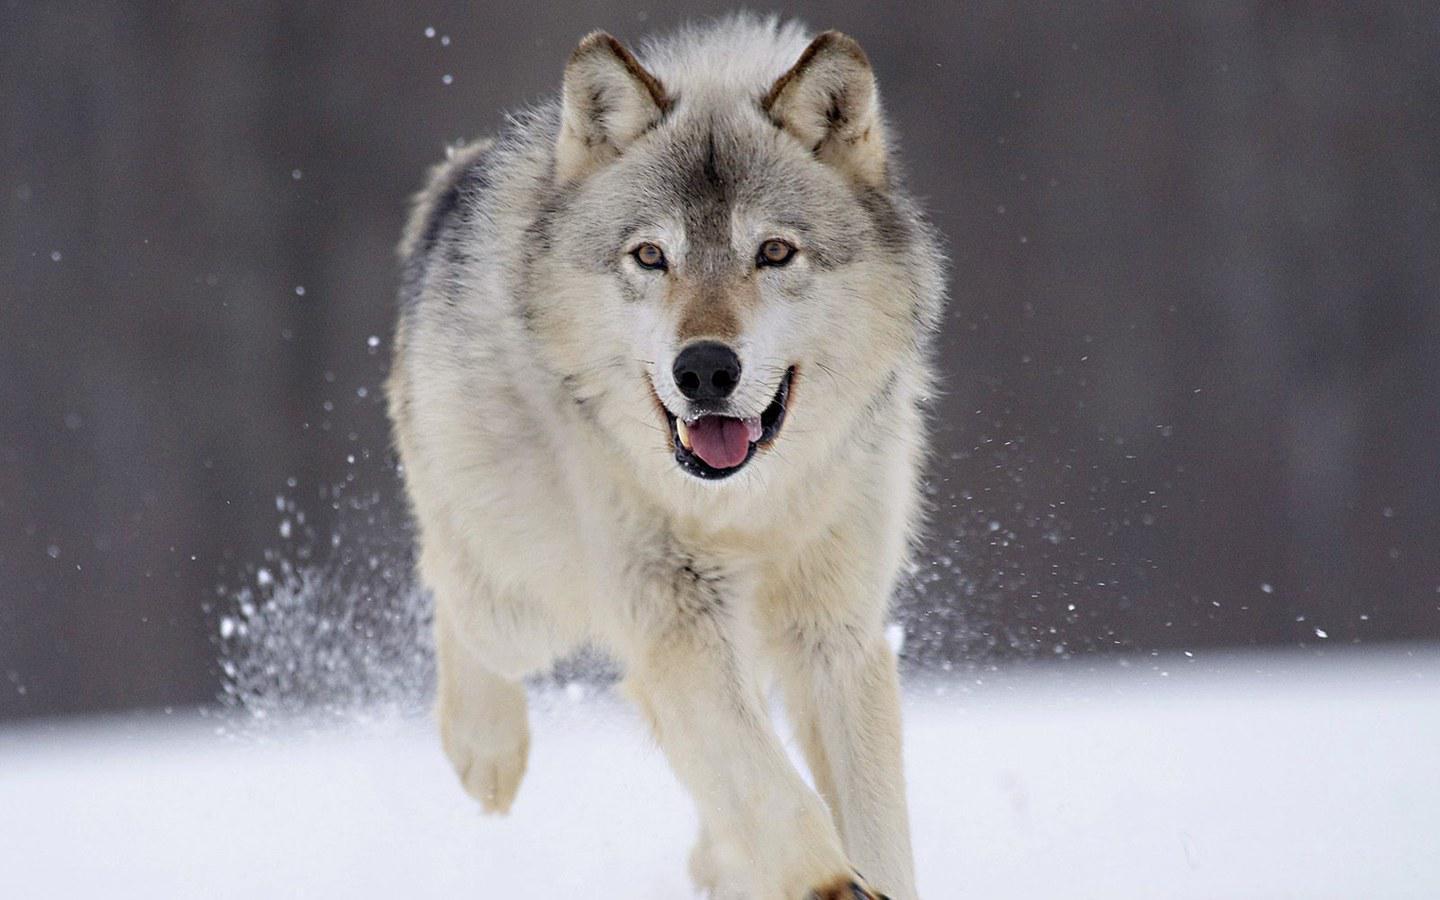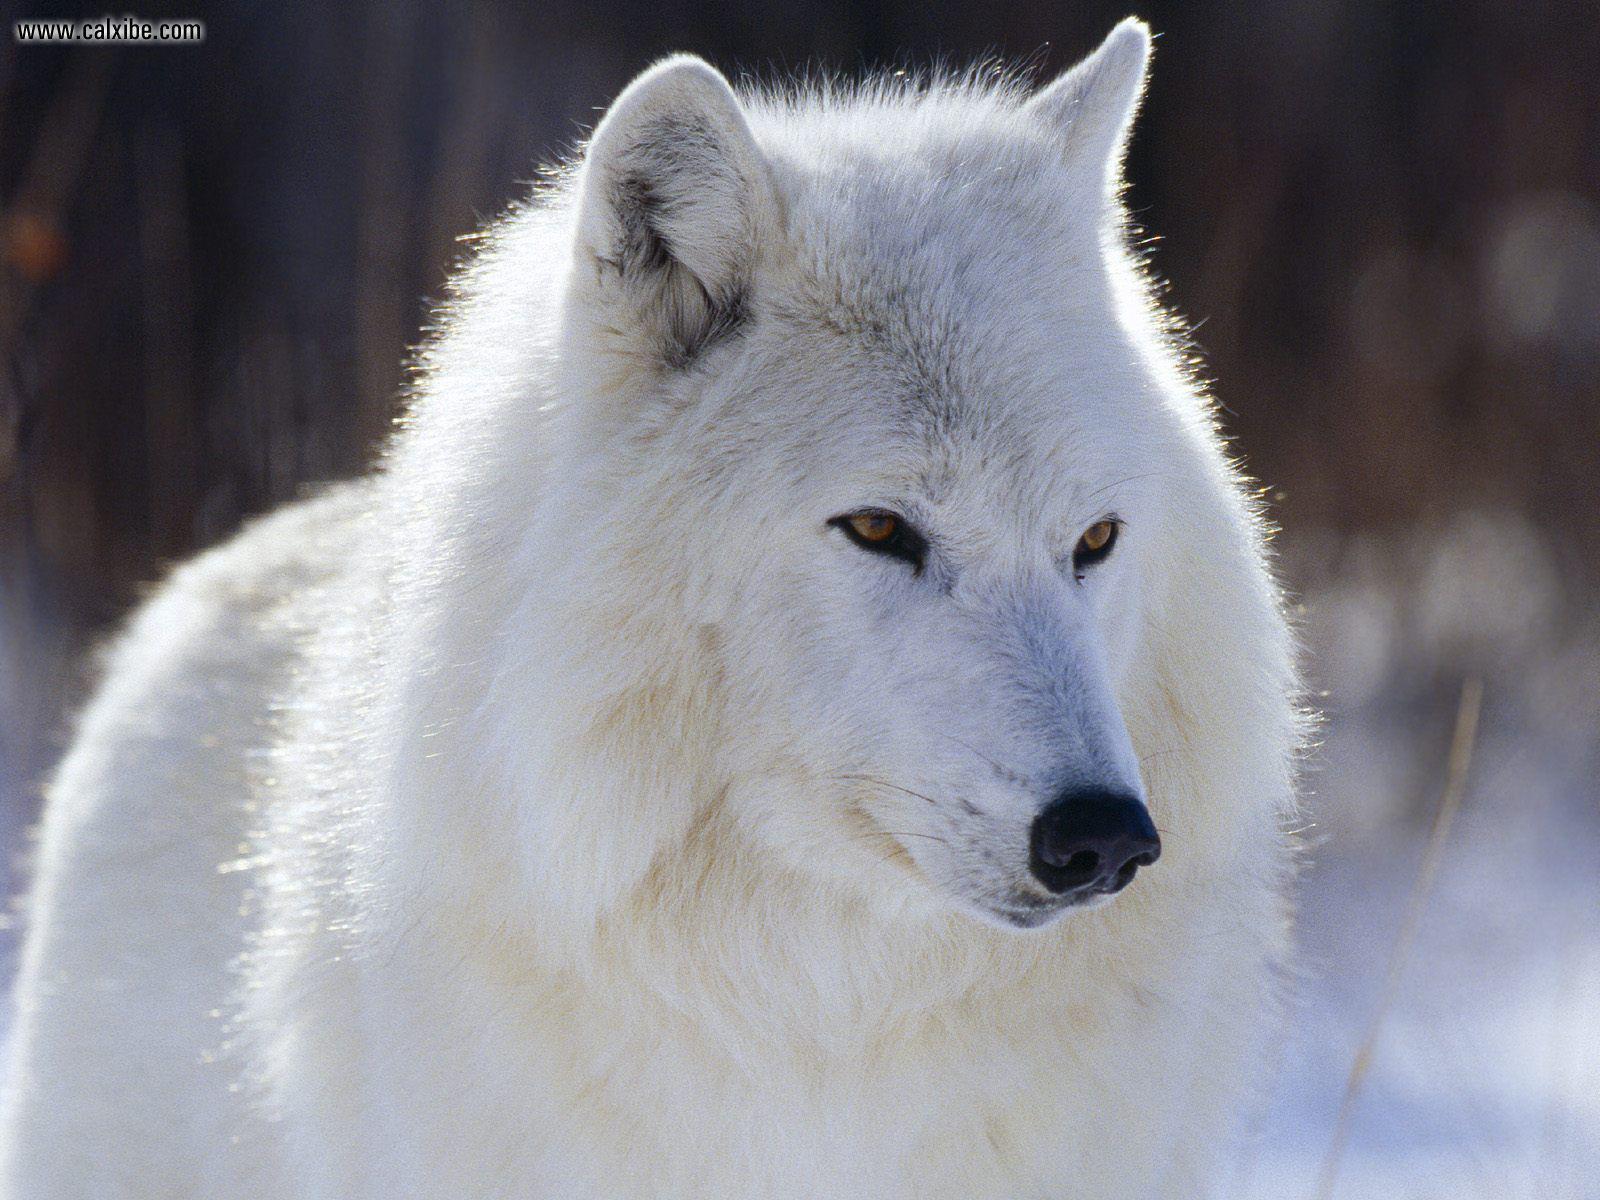The first image is the image on the left, the second image is the image on the right. Evaluate the accuracy of this statement regarding the images: "The left image includes a dog moving forward over snow toward the camera, and it includes a dog with an open mouth.". Is it true? Answer yes or no. Yes. The first image is the image on the left, the second image is the image on the right. Given the left and right images, does the statement "There are fewer than four wolves." hold true? Answer yes or no. Yes. 